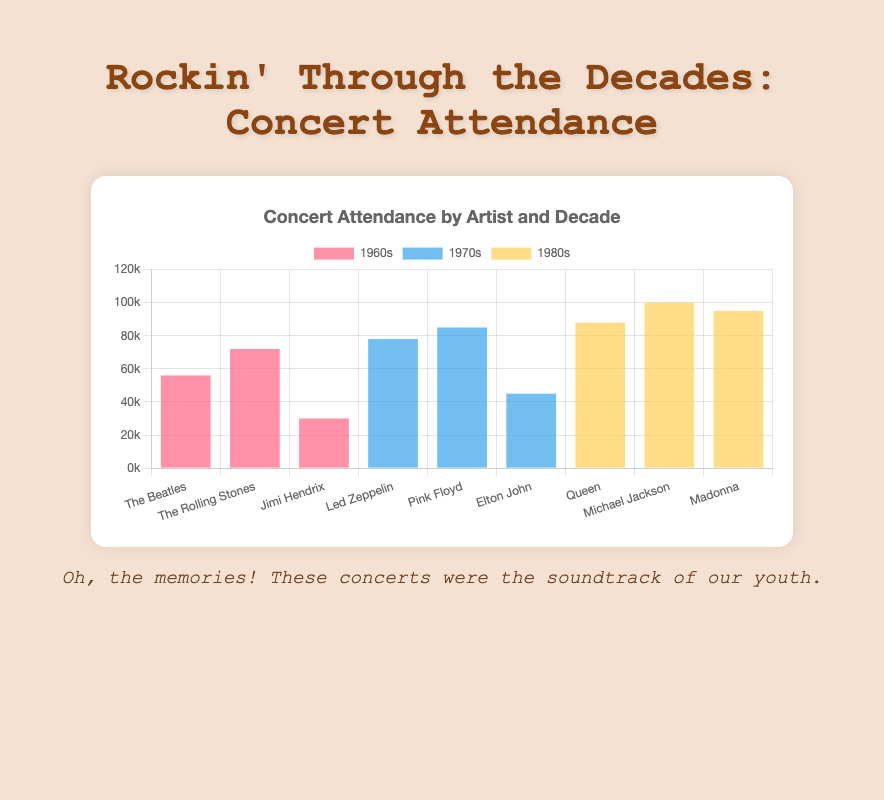Which artist had the highest concert attendance in the 1980s? In the 1980s dataset, Michael Jackson had the attendance count of 100,000 which is the highest compared to Queen (88,000) and Madonna (95,000).
Answer: Michael Jackson How many people attended The Beatles concert in the 1960s? Looking at the bar labeled 'The Beatles' under the 1960s group, the attendance is shown as 56,000.
Answer: 56,000 What was the total attendance for The Rolling Stones in the 1960s and Led Zeppelin in the 1970s? The Rolling Stones in the 1960s had an attendance of 72,000 and Led Zeppelin in the 1970s had 78,000. Adding these together gives 72,000 + 78,000 = 150,000.
Answer: 150,000 Who had more concert attendees in the 1970s: Led Zeppelin or Pink Floyd? By comparing the attendance, Led Zeppelin had 78,000 and Pink Floyd had 85,000 in the 1970s. Pink Floyd had more attendees.
Answer: Pink Floyd Which decade had the highest total concert attendance for all listed artists? Summing up the attendance for each decade: 1960s: 56,000 + 72,000 + 30,000 = 158,000, 1970s: 78,000 + 85,000 + 45,000 = 208,000, 1980s: 88,000 + 100,000 + 95,000 = 283,000. The 1980s had the highest total attendance of 283,000.
Answer: 1980s What is the attendance difference between Jimi Hendrix in the 1960s and Elton John in the 1970s? Jimi Hendrix had an attendance of 30,000 in the 1960s while Elton John had 45,000 in the 1970s. The difference is 45,000 - 30,000 = 15,000.
Answer: 15,000 Which artist's concert bar is depicted in blue color in the chart? The dataset labeled "1970s" uses blue color and includes Led Zeppelin, Pink Floyd, and Elton John.
Answer: Led Zeppelin, Pink Floyd, and Elton John What was the average concert attendance for artists in the 1960s? Adding the individual attendance: 56,000 + 72,000 + 30,000 = 158,000. Dividing by the number of artists (3): 158,000 / 3 = 52,666.67.
Answer: 52,666.67 Did Queen have more or less concert attendance compared to Madonna in the 1980s? In the 1980s, Queen had 88,000 attendees while Madonna had 95,000 attendees. Therefore, Queen had less.
Answer: Less How does the height of the bar for Michael Jackson in the 1980s compare to that of Jimi Hendrix in the 1960s? Michael Jackson's bar, which represents an attendance of 100,000, is significantly taller compared to Jimi Hendrix's bar, which represents an attendance of 30,000.
Answer: Much taller‍ 